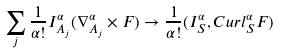<formula> <loc_0><loc_0><loc_500><loc_500>\sum _ { j } \frac { 1 } { \alpha ! } { I _ { A _ { j } } ^ { \alpha } } ( { \nabla _ { A _ { j } } ^ { \alpha } } \times F ) \rightarrow \frac { 1 } { \alpha ! } ( { I _ { S } ^ { \alpha } } , { C u r l _ { S } ^ { \alpha } } F )</formula> 